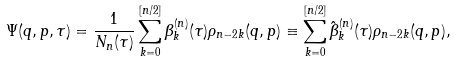Convert formula to latex. <formula><loc_0><loc_0><loc_500><loc_500>\Psi ( q , p , \tau ) = \frac { 1 } { N _ { n } ( \tau ) } \sum _ { k = 0 } ^ { [ n / 2 ] } \beta ^ { ( n ) } _ { k } ( \tau ) \rho _ { n - 2 k } ( q , p ) \equiv \sum _ { k = 0 } ^ { [ n / 2 ] } \hat { \beta } ^ { ( n ) } _ { k } ( \tau ) \rho _ { n - 2 k } ( q , p ) ,</formula> 